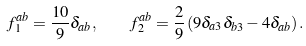<formula> <loc_0><loc_0><loc_500><loc_500>f ^ { a b } _ { 1 } = \frac { 1 0 } { 9 } \delta _ { a b } , \quad f ^ { a b } _ { 2 } = \frac { 2 } { 9 } \left ( 9 \delta _ { a 3 } \delta _ { b 3 } - 4 \delta _ { a b } \right ) .</formula> 